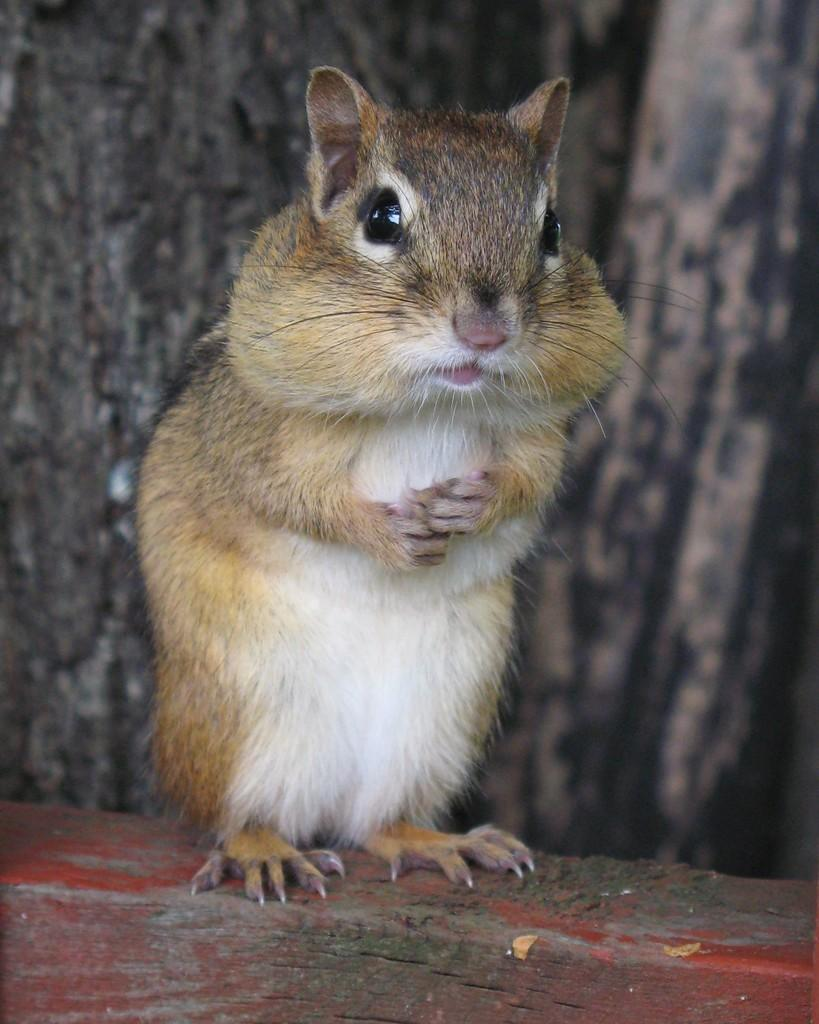What animal can be seen in the image? There is a squirrel in the image. What is the squirrel standing on? The squirrel is standing on a wooden log. Can you describe the background of the image? The background of the image is blurred. How much dirt is on the squirrel's paws in the image? There is no dirt visible on the squirrel's paws in the image. What does the squirrel say about itself in the image? The squirrel cannot speak, so there is no self-description in the image. 